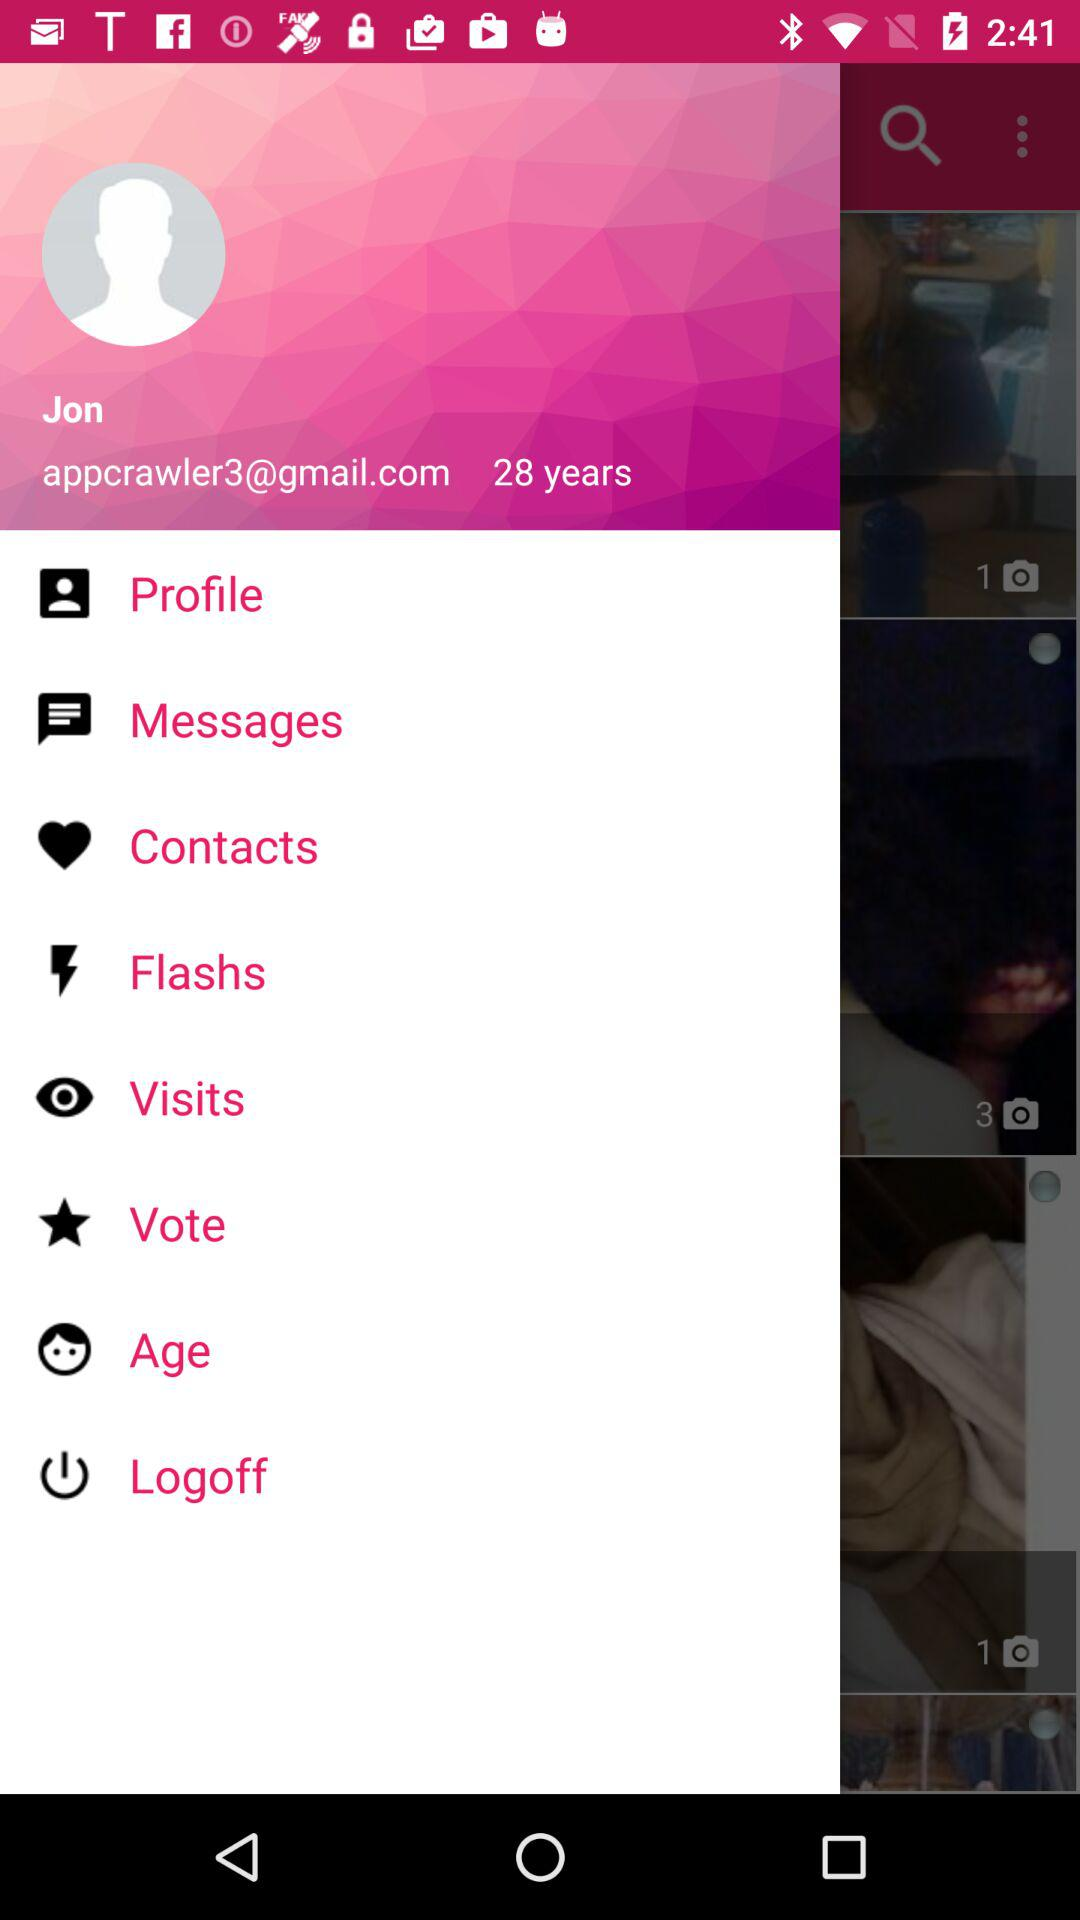What is the age of the user? The age of the user is 28 years. 